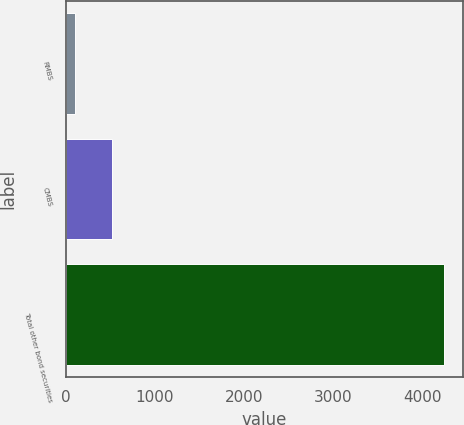Convert chart to OTSL. <chart><loc_0><loc_0><loc_500><loc_500><bar_chart><fcel>RMBS<fcel>CMBS<fcel>Total other bond securities<nl><fcel>109<fcel>522.4<fcel>4243<nl></chart> 